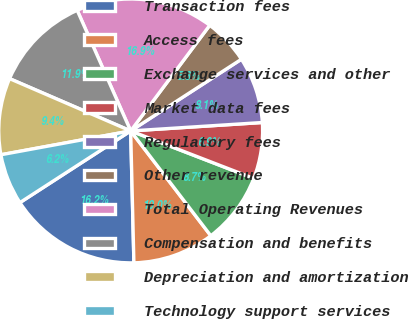<chart> <loc_0><loc_0><loc_500><loc_500><pie_chart><fcel>Transaction fees<fcel>Access fees<fcel>Exchange services and other<fcel>Market data fees<fcel>Regulatory fees<fcel>Other revenue<fcel>Total Operating Revenues<fcel>Compensation and benefits<fcel>Depreciation and amortization<fcel>Technology support services<nl><fcel>16.25%<fcel>10.0%<fcel>8.75%<fcel>6.88%<fcel>8.13%<fcel>5.63%<fcel>16.87%<fcel>11.87%<fcel>9.38%<fcel>6.25%<nl></chart> 